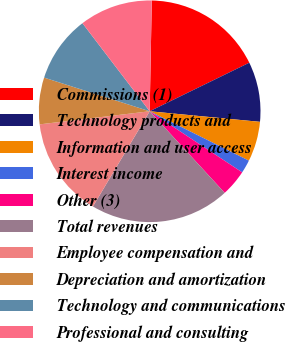Convert chart to OTSL. <chart><loc_0><loc_0><loc_500><loc_500><pie_chart><fcel>Commissions (1)<fcel>Technology products and<fcel>Information and user access<fcel>Interest income<fcel>Other (3)<fcel>Total revenues<fcel>Employee compensation and<fcel>Depreciation and amortization<fcel>Technology and communications<fcel>Professional and consulting<nl><fcel>17.48%<fcel>8.74%<fcel>5.83%<fcel>1.94%<fcel>3.88%<fcel>20.39%<fcel>14.56%<fcel>6.8%<fcel>9.71%<fcel>10.68%<nl></chart> 